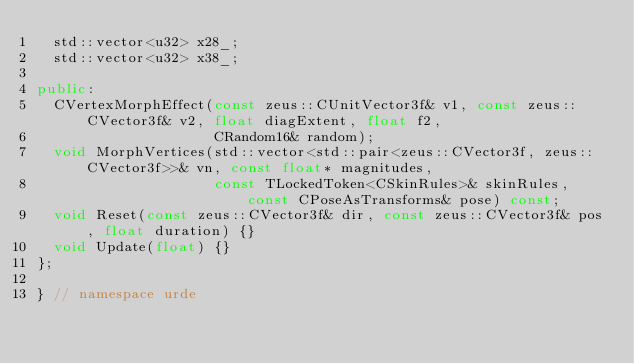<code> <loc_0><loc_0><loc_500><loc_500><_C++_>  std::vector<u32> x28_;
  std::vector<u32> x38_;

public:
  CVertexMorphEffect(const zeus::CUnitVector3f& v1, const zeus::CVector3f& v2, float diagExtent, float f2,
                     CRandom16& random);
  void MorphVertices(std::vector<std::pair<zeus::CVector3f, zeus::CVector3f>>& vn, const float* magnitudes,
                     const TLockedToken<CSkinRules>& skinRules, const CPoseAsTransforms& pose) const;
  void Reset(const zeus::CVector3f& dir, const zeus::CVector3f& pos, float duration) {}
  void Update(float) {}
};

} // namespace urde
</code> 